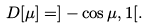Convert formula to latex. <formula><loc_0><loc_0><loc_500><loc_500>D [ \mu ] = ] - \cos \mu , 1 [ .</formula> 